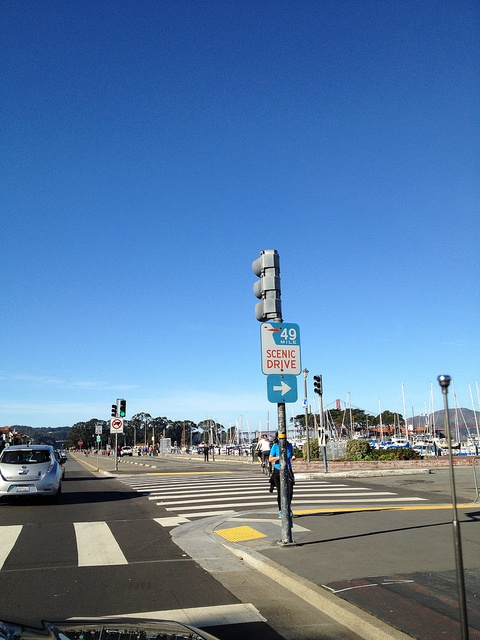Describe the objects in this image and their specific colors. I can see car in darkblue, black, gray, darkgray, and lightgray tones, traffic light in darkblue, darkgray, black, lightgray, and navy tones, people in darkblue, black, gray, navy, and lightblue tones, boat in darkblue, darkgray, lightgray, gray, and black tones, and people in darkblue, white, black, and gray tones in this image. 